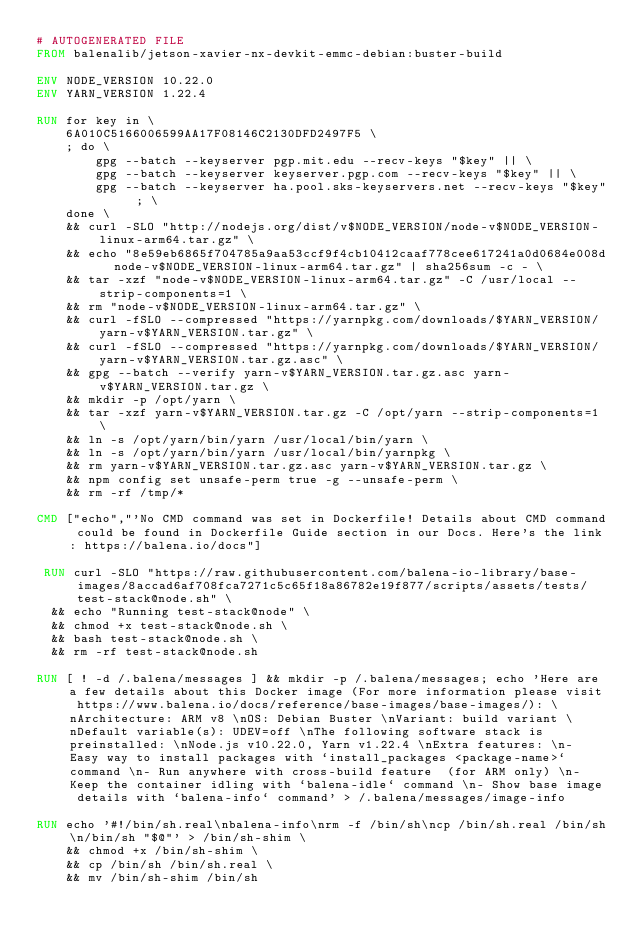Convert code to text. <code><loc_0><loc_0><loc_500><loc_500><_Dockerfile_># AUTOGENERATED FILE
FROM balenalib/jetson-xavier-nx-devkit-emmc-debian:buster-build

ENV NODE_VERSION 10.22.0
ENV YARN_VERSION 1.22.4

RUN for key in \
	6A010C5166006599AA17F08146C2130DFD2497F5 \
	; do \
		gpg --batch --keyserver pgp.mit.edu --recv-keys "$key" || \
		gpg --batch --keyserver keyserver.pgp.com --recv-keys "$key" || \
		gpg --batch --keyserver ha.pool.sks-keyservers.net --recv-keys "$key" ; \
	done \
	&& curl -SLO "http://nodejs.org/dist/v$NODE_VERSION/node-v$NODE_VERSION-linux-arm64.tar.gz" \
	&& echo "8e59eb6865f704785a9aa53ccf9f4cb10412caaf778cee617241a0d0684e008d  node-v$NODE_VERSION-linux-arm64.tar.gz" | sha256sum -c - \
	&& tar -xzf "node-v$NODE_VERSION-linux-arm64.tar.gz" -C /usr/local --strip-components=1 \
	&& rm "node-v$NODE_VERSION-linux-arm64.tar.gz" \
	&& curl -fSLO --compressed "https://yarnpkg.com/downloads/$YARN_VERSION/yarn-v$YARN_VERSION.tar.gz" \
	&& curl -fSLO --compressed "https://yarnpkg.com/downloads/$YARN_VERSION/yarn-v$YARN_VERSION.tar.gz.asc" \
	&& gpg --batch --verify yarn-v$YARN_VERSION.tar.gz.asc yarn-v$YARN_VERSION.tar.gz \
	&& mkdir -p /opt/yarn \
	&& tar -xzf yarn-v$YARN_VERSION.tar.gz -C /opt/yarn --strip-components=1 \
	&& ln -s /opt/yarn/bin/yarn /usr/local/bin/yarn \
	&& ln -s /opt/yarn/bin/yarn /usr/local/bin/yarnpkg \
	&& rm yarn-v$YARN_VERSION.tar.gz.asc yarn-v$YARN_VERSION.tar.gz \
	&& npm config set unsafe-perm true -g --unsafe-perm \
	&& rm -rf /tmp/*

CMD ["echo","'No CMD command was set in Dockerfile! Details about CMD command could be found in Dockerfile Guide section in our Docs. Here's the link: https://balena.io/docs"]

 RUN curl -SLO "https://raw.githubusercontent.com/balena-io-library/base-images/8accad6af708fca7271c5c65f18a86782e19f877/scripts/assets/tests/test-stack@node.sh" \
  && echo "Running test-stack@node" \
  && chmod +x test-stack@node.sh \
  && bash test-stack@node.sh \
  && rm -rf test-stack@node.sh 

RUN [ ! -d /.balena/messages ] && mkdir -p /.balena/messages; echo 'Here are a few details about this Docker image (For more information please visit https://www.balena.io/docs/reference/base-images/base-images/): \nArchitecture: ARM v8 \nOS: Debian Buster \nVariant: build variant \nDefault variable(s): UDEV=off \nThe following software stack is preinstalled: \nNode.js v10.22.0, Yarn v1.22.4 \nExtra features: \n- Easy way to install packages with `install_packages <package-name>` command \n- Run anywhere with cross-build feature  (for ARM only) \n- Keep the container idling with `balena-idle` command \n- Show base image details with `balena-info` command' > /.balena/messages/image-info

RUN echo '#!/bin/sh.real\nbalena-info\nrm -f /bin/sh\ncp /bin/sh.real /bin/sh\n/bin/sh "$@"' > /bin/sh-shim \
	&& chmod +x /bin/sh-shim \
	&& cp /bin/sh /bin/sh.real \
	&& mv /bin/sh-shim /bin/sh</code> 